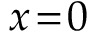<formula> <loc_0><loc_0><loc_500><loc_500>x \, = \, 0</formula> 